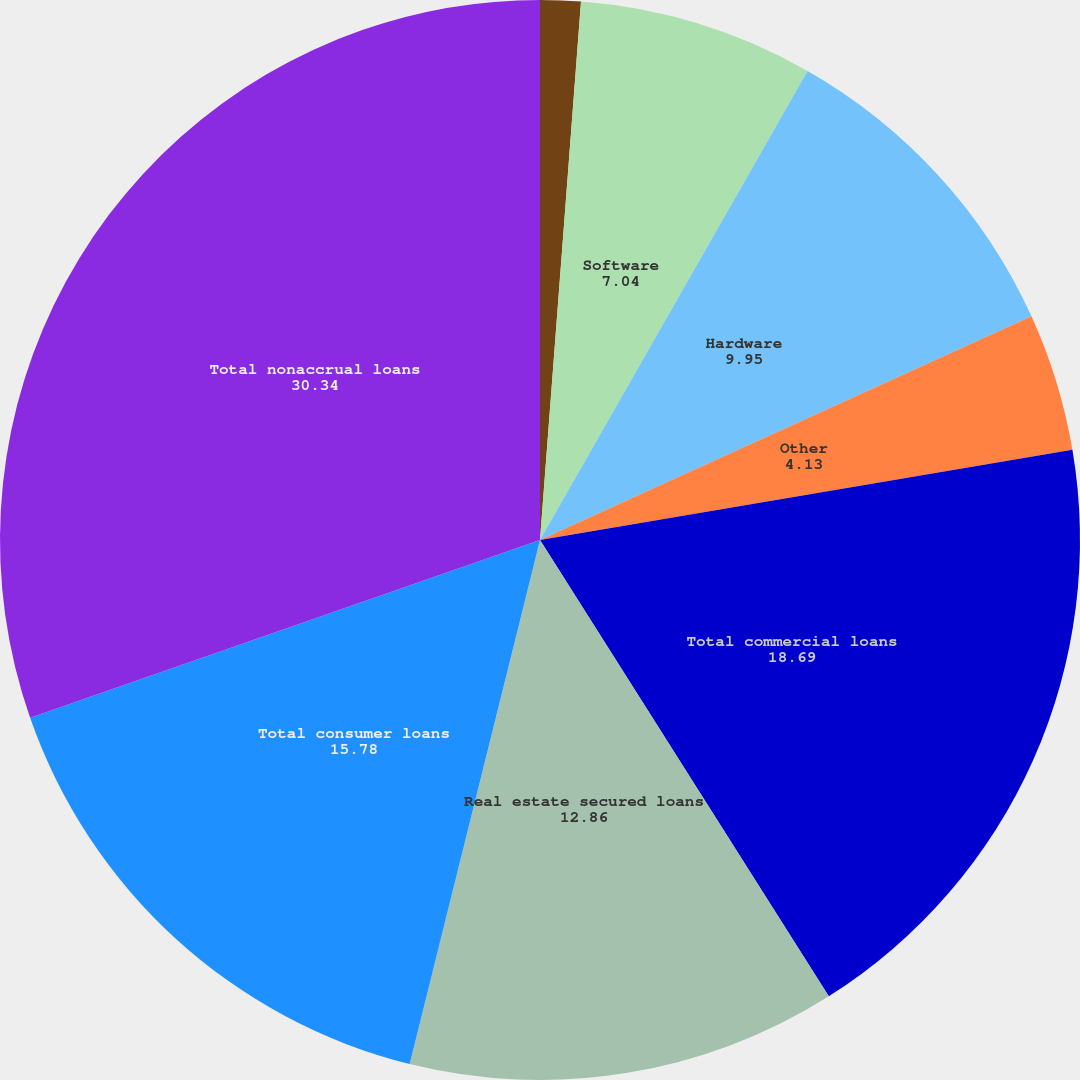<chart> <loc_0><loc_0><loc_500><loc_500><pie_chart><fcel>(Dollars in thousands)<fcel>Software<fcel>Hardware<fcel>Other<fcel>Total commercial loans<fcel>Real estate secured loans<fcel>Total consumer loans<fcel>Total nonaccrual loans<nl><fcel>1.21%<fcel>7.04%<fcel>9.95%<fcel>4.13%<fcel>18.69%<fcel>12.86%<fcel>15.78%<fcel>30.34%<nl></chart> 